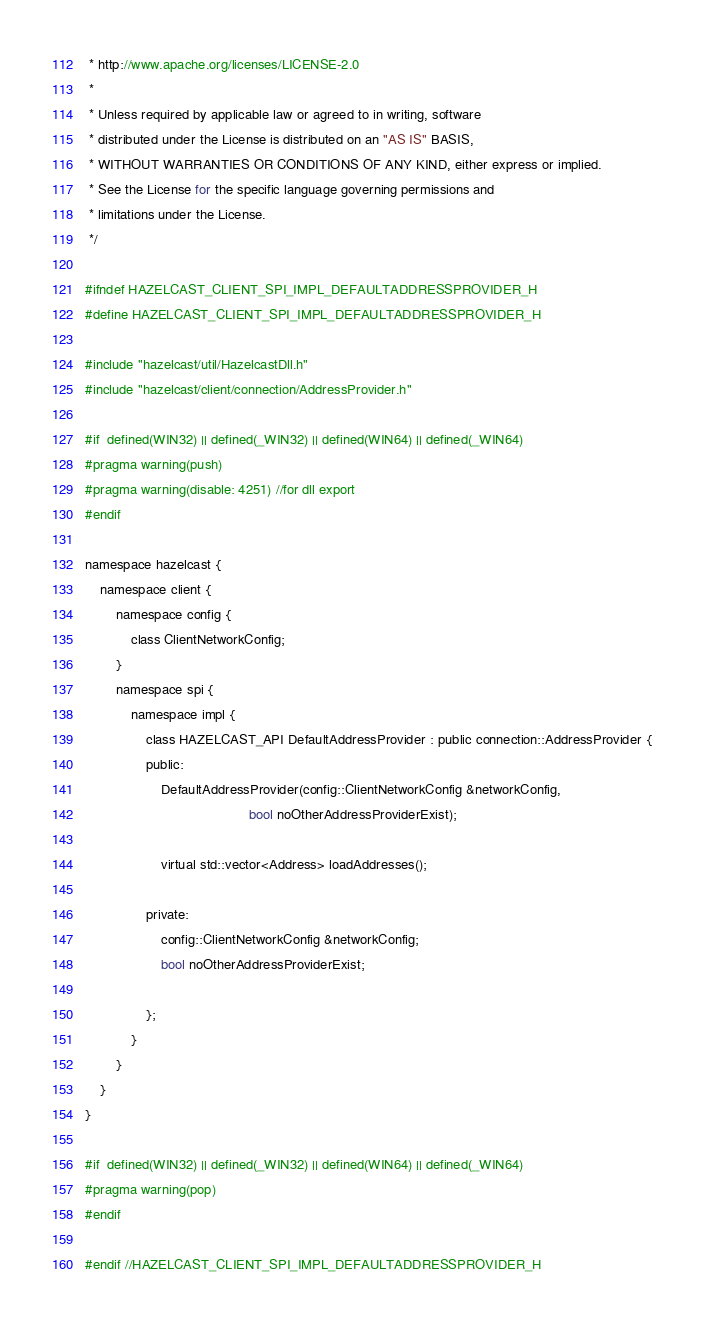<code> <loc_0><loc_0><loc_500><loc_500><_C_> * http://www.apache.org/licenses/LICENSE-2.0
 *
 * Unless required by applicable law or agreed to in writing, software
 * distributed under the License is distributed on an "AS IS" BASIS,
 * WITHOUT WARRANTIES OR CONDITIONS OF ANY KIND, either express or implied.
 * See the License for the specific language governing permissions and
 * limitations under the License.
 */

#ifndef HAZELCAST_CLIENT_SPI_IMPL_DEFAULTADDRESSPROVIDER_H
#define HAZELCAST_CLIENT_SPI_IMPL_DEFAULTADDRESSPROVIDER_H

#include "hazelcast/util/HazelcastDll.h"
#include "hazelcast/client/connection/AddressProvider.h"

#if  defined(WIN32) || defined(_WIN32) || defined(WIN64) || defined(_WIN64)
#pragma warning(push)
#pragma warning(disable: 4251) //for dll export
#endif

namespace hazelcast {
    namespace client {
        namespace config {
            class ClientNetworkConfig;
        }
        namespace spi {
            namespace impl {
                class HAZELCAST_API DefaultAddressProvider : public connection::AddressProvider {
                public:
                    DefaultAddressProvider(config::ClientNetworkConfig &networkConfig,
                                           bool noOtherAddressProviderExist);

                    virtual std::vector<Address> loadAddresses();

                private:
                    config::ClientNetworkConfig &networkConfig;
                    bool noOtherAddressProviderExist;

                };
            }
        }
    }
}

#if  defined(WIN32) || defined(_WIN32) || defined(WIN64) || defined(_WIN64)
#pragma warning(pop)
#endif

#endif //HAZELCAST_CLIENT_SPI_IMPL_DEFAULTADDRESSPROVIDER_H
</code> 